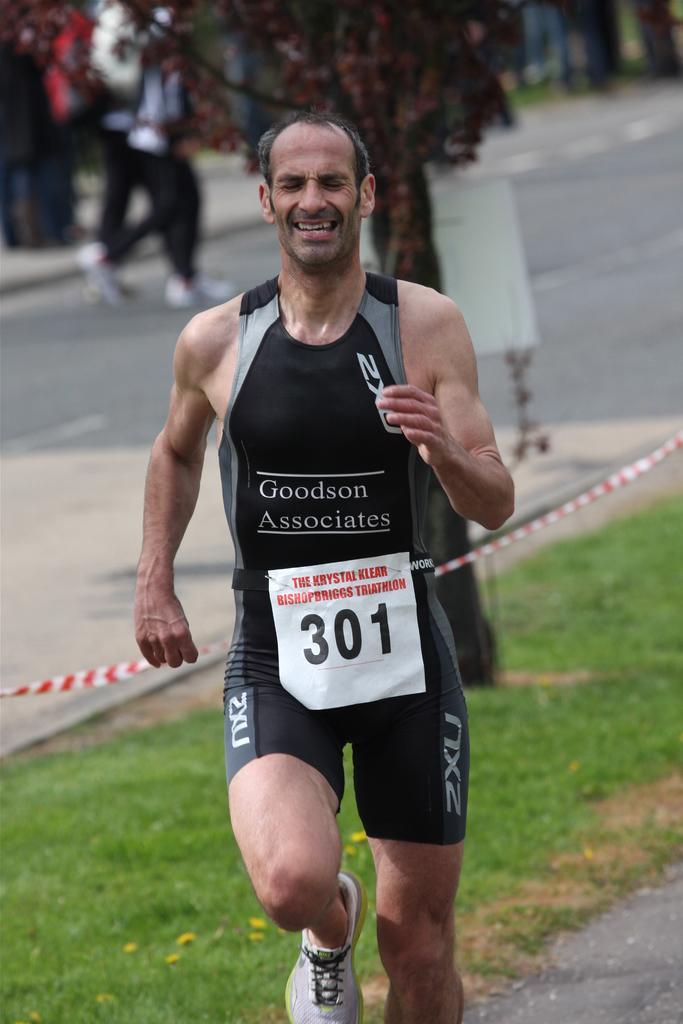<image>
Relay a brief, clear account of the picture shown. a sign on a runner that says 301 on it 